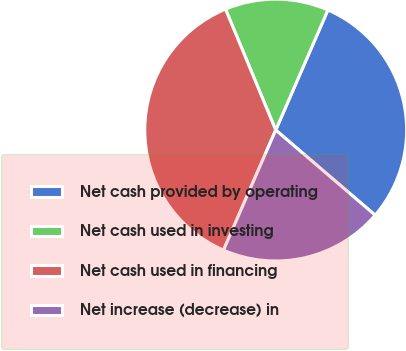Convert chart to OTSL. <chart><loc_0><loc_0><loc_500><loc_500><pie_chart><fcel>Net cash provided by operating<fcel>Net cash used in investing<fcel>Net cash used in financing<fcel>Net increase (decrease) in<nl><fcel>29.74%<fcel>12.79%<fcel>37.21%<fcel>20.26%<nl></chart> 